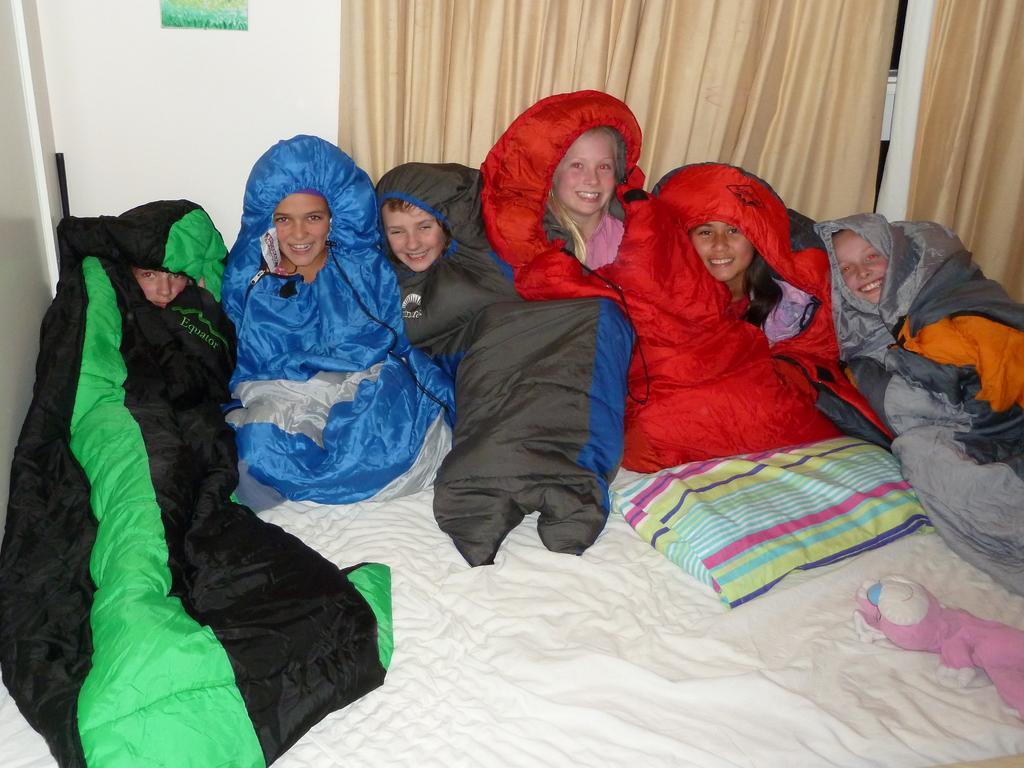Describe this image in one or two sentences. In this picture I can see few people on the bed and I can see a pillow and a soft toy and I can see curtains in the back and a poster on the wall. 